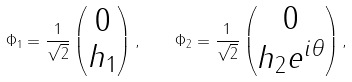Convert formula to latex. <formula><loc_0><loc_0><loc_500><loc_500>\Phi _ { 1 } = \frac { 1 } { \sqrt { 2 } } \begin{pmatrix} 0 \\ h _ { 1 } \end{pmatrix} , \quad \Phi _ { 2 } = \frac { 1 } { \sqrt { 2 } } \begin{pmatrix} 0 \\ h _ { 2 } e ^ { i \theta } \end{pmatrix} ,</formula> 